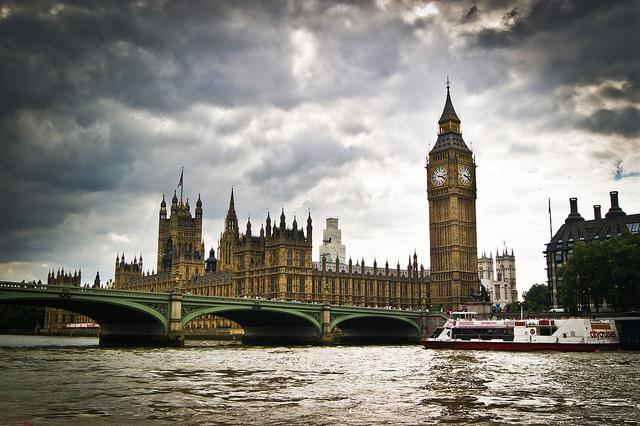Is the sky clear?
Give a very brief answer. No. What is the name of the tower?
Quick response, please. Big ben. Is the water calm?
Give a very brief answer. Yes. Does the tower have a light shining from the ground?
Answer briefly. No. Is the building a castle?
Keep it brief. No. What is on the water?
Short answer required. Boat. 